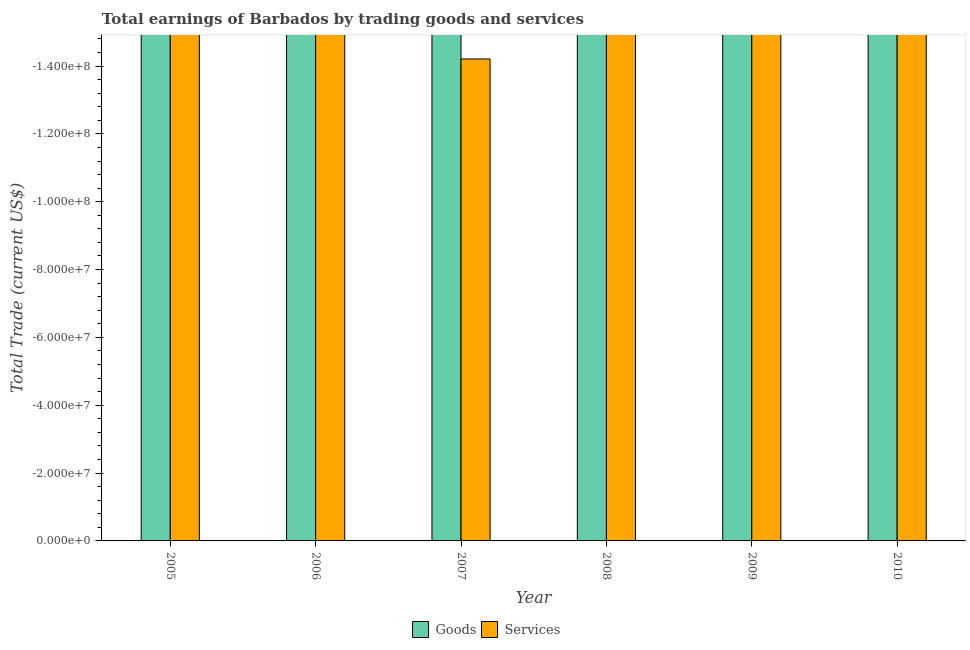Are the number of bars on each tick of the X-axis equal?
Give a very brief answer. Yes. What is the difference between the amount earned by trading services in 2008 and the amount earned by trading goods in 2010?
Your answer should be compact. 0. What is the average amount earned by trading goods per year?
Your answer should be compact. 0. In how many years, is the amount earned by trading services greater than -128000000 US$?
Give a very brief answer. 0. In how many years, is the amount earned by trading services greater than the average amount earned by trading services taken over all years?
Ensure brevity in your answer.  0. How many bars are there?
Provide a succinct answer. 0. Does the graph contain any zero values?
Make the answer very short. Yes. Does the graph contain grids?
Give a very brief answer. No. How are the legend labels stacked?
Keep it short and to the point. Horizontal. What is the title of the graph?
Your answer should be compact. Total earnings of Barbados by trading goods and services. What is the label or title of the Y-axis?
Offer a terse response. Total Trade (current US$). What is the Total Trade (current US$) in Services in 2005?
Provide a succinct answer. 0. What is the Total Trade (current US$) in Goods in 2006?
Offer a terse response. 0. What is the Total Trade (current US$) in Goods in 2007?
Ensure brevity in your answer.  0. What is the total Total Trade (current US$) of Goods in the graph?
Your response must be concise. 0. What is the average Total Trade (current US$) in Services per year?
Provide a short and direct response. 0. 